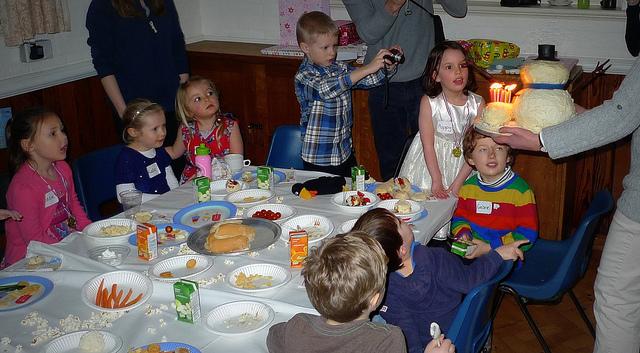How many candles can you see?
Be succinct. 6. Whose birthday is it?
Quick response, please. Boys. How many people are in the picture?
Give a very brief answer. 11. Which side of the table are the small tomatoes on?
Answer briefly. Right. 